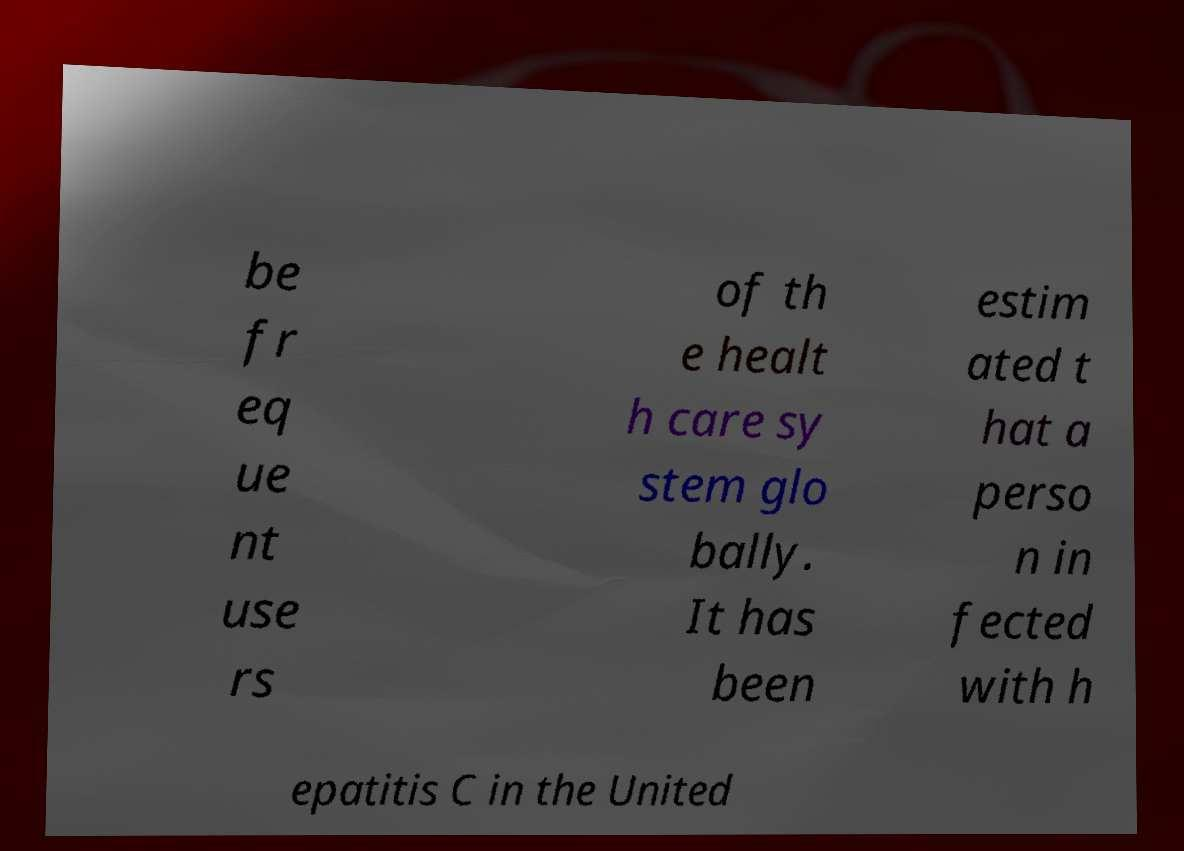Please read and relay the text visible in this image. What does it say? be fr eq ue nt use rs of th e healt h care sy stem glo bally. It has been estim ated t hat a perso n in fected with h epatitis C in the United 